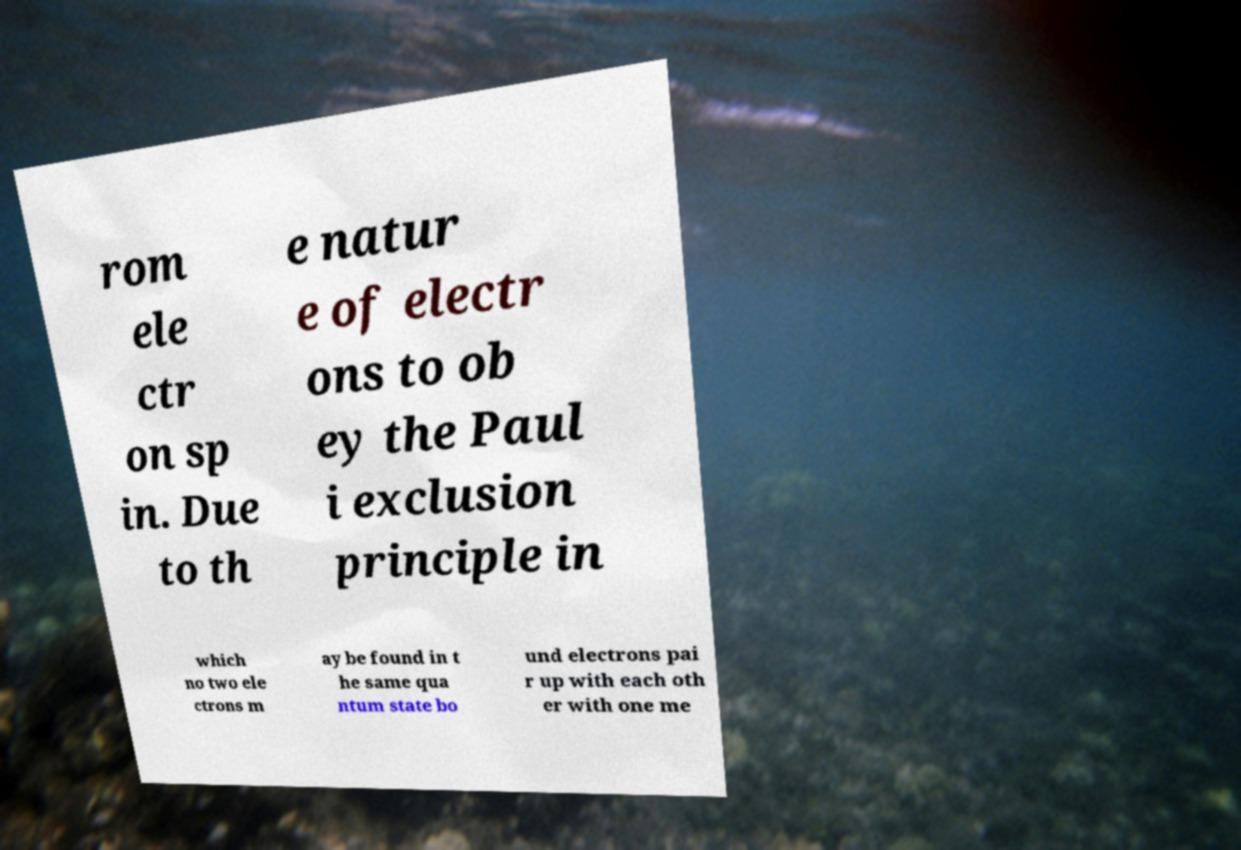There's text embedded in this image that I need extracted. Can you transcribe it verbatim? rom ele ctr on sp in. Due to th e natur e of electr ons to ob ey the Paul i exclusion principle in which no two ele ctrons m ay be found in t he same qua ntum state bo und electrons pai r up with each oth er with one me 